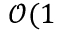Convert formula to latex. <formula><loc_0><loc_0><loc_500><loc_500>\mathcal { O } ( 1 \</formula> 